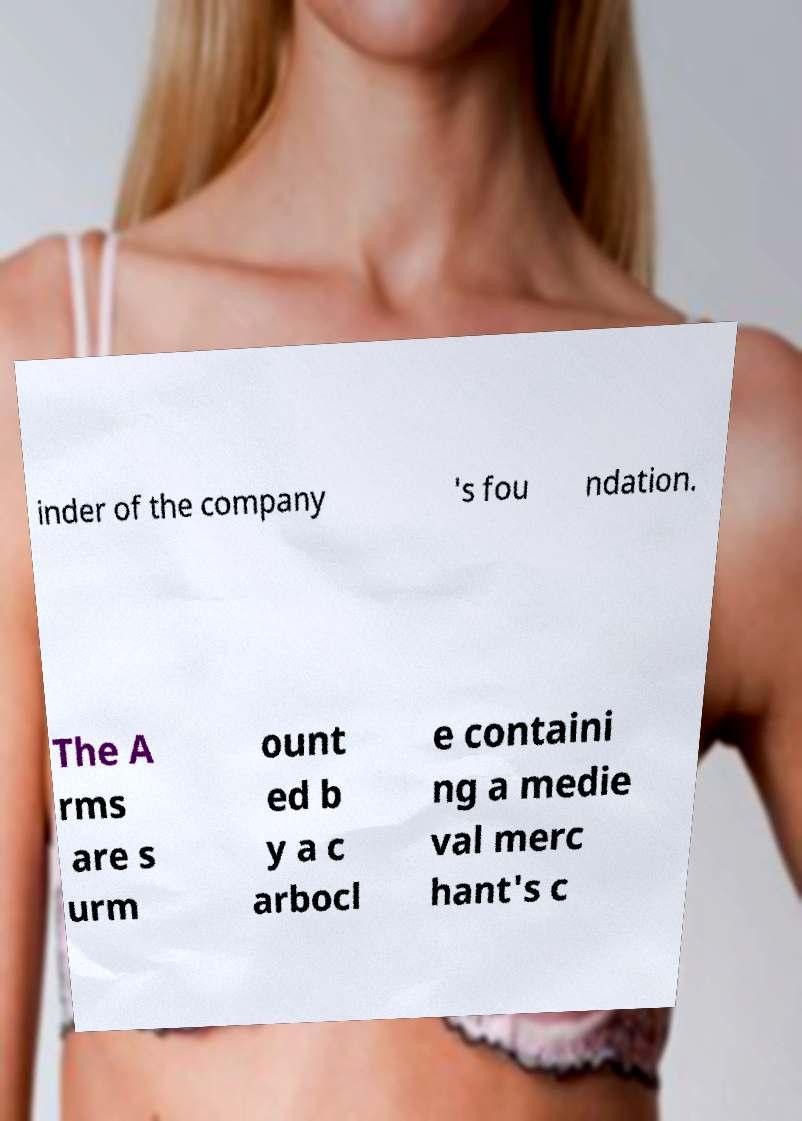Can you accurately transcribe the text from the provided image for me? inder of the company 's fou ndation. The A rms are s urm ount ed b y a c arbocl e containi ng a medie val merc hant's c 